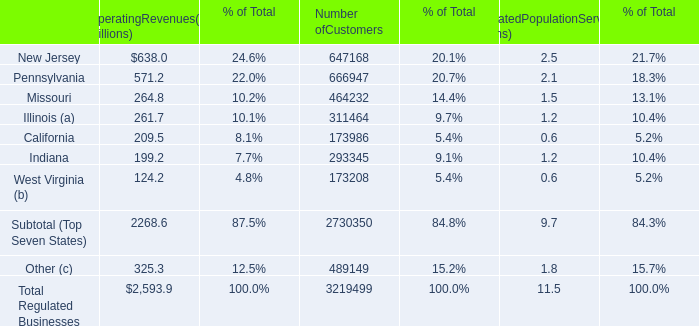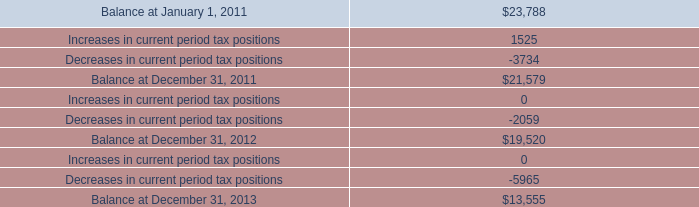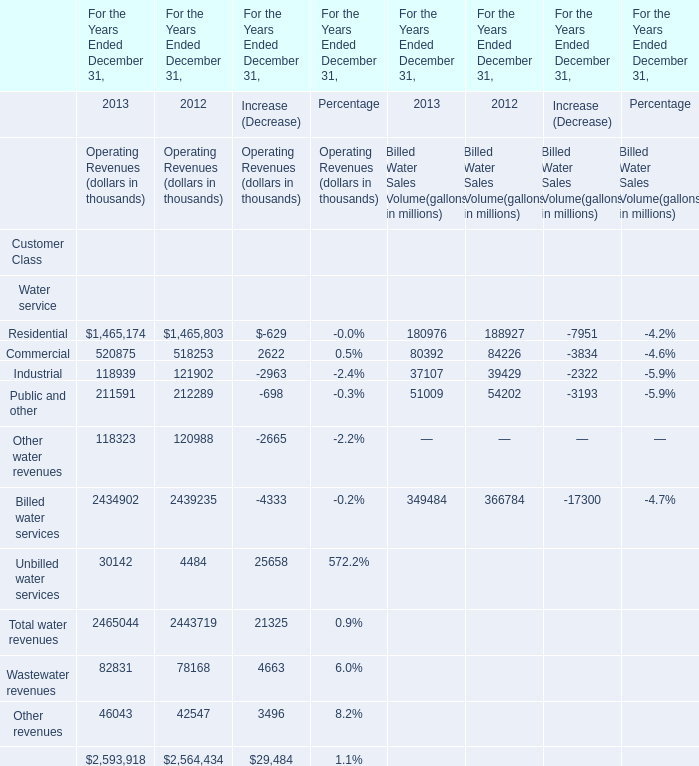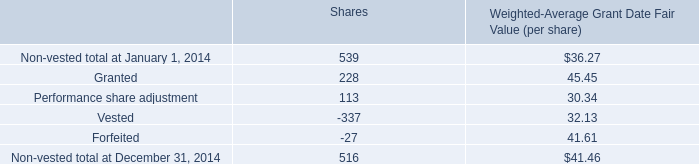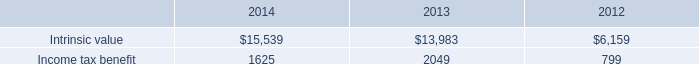Which Water service keeps increasing between 2013 and 2012? 
Answer: Commercial. 